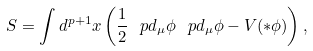<formula> <loc_0><loc_0><loc_500><loc_500>S = \int d ^ { p + 1 } x \left ( \frac { 1 } { 2 } \ p d _ { \mu } \phi \ p d _ { \mu } \phi - V ( * \phi ) \right ) ,</formula> 